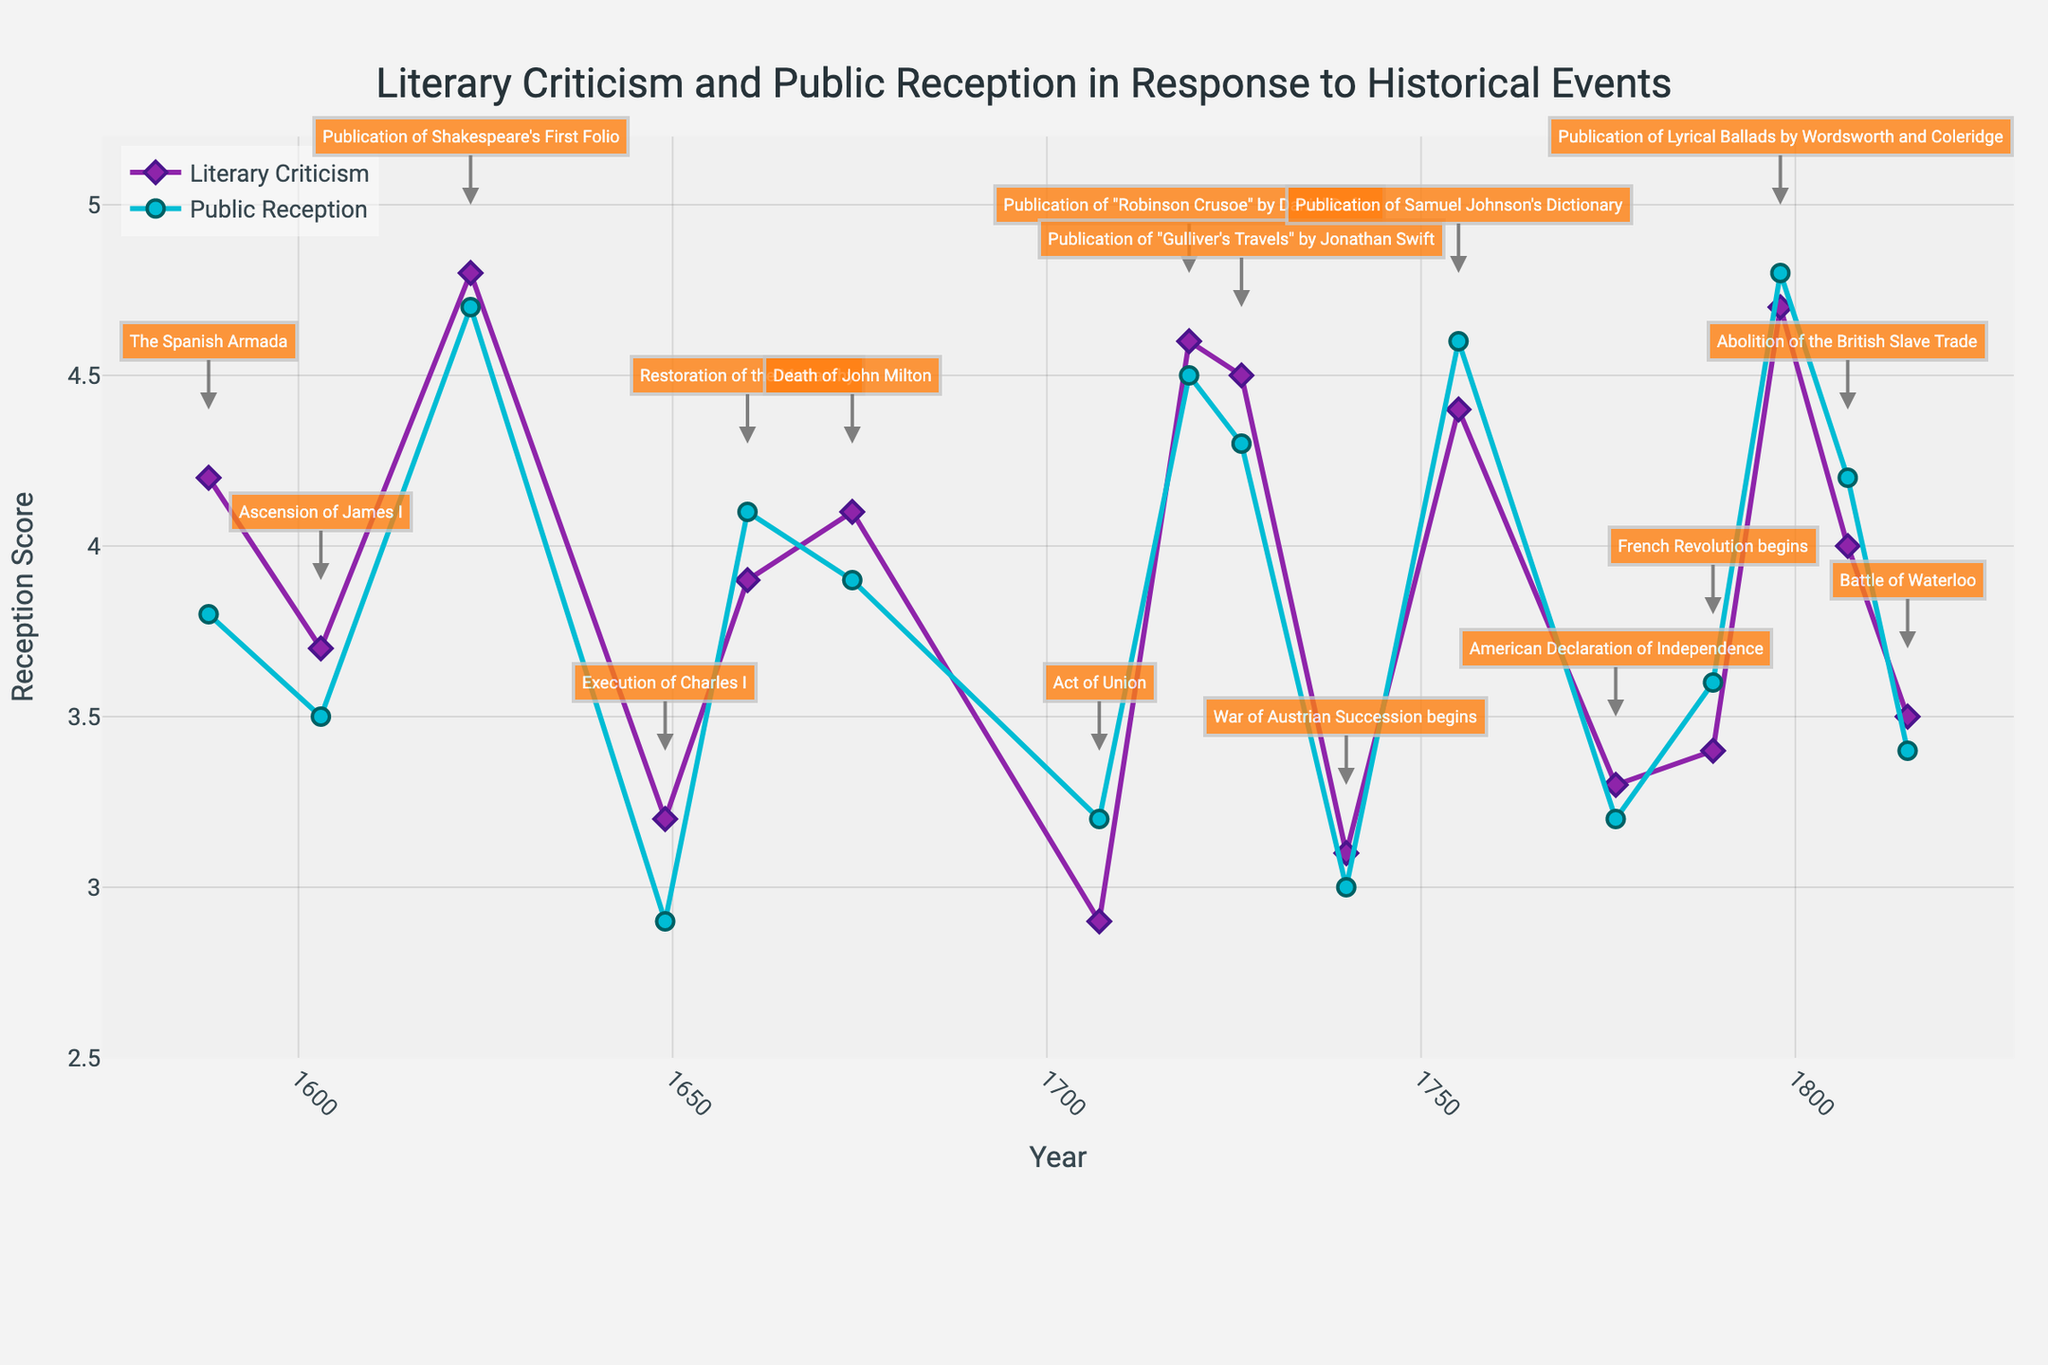what is the title of the chart? The title of the chart is displayed at the top and reads "Literary Criticism and Public Reception in Response to Historical Events".
Answer: Literary Criticism and Public Reception in Response to Historical Events Which years have the highest public reception scores? First, identify the public reception scores from the graph and cross-reference them with their respective years. The highest public reception scores are around 4.8 and 4.7, which correspond to the years 1798 and 1623 respectively.
Answer: 1798 and 1623 How many historical events are annotated in the plot? Count the number of annotations visible on the plot. Each annotation indicates a historical event. Based on the data provided, there are annotations for every year-event pair.
Answer: 15 What is the average literary criticism score for the events in the 18th century (1701-1800)? Identify the literary criticism scores between 1701 and 1800 from the dataset: 2.9 (1707), 4.6 (1719), 4.5 (1726), 3.1 (1740), 4.4 (1755), 3.3 (1776), 3.4 (1789). Sum these values and divide by the number of data points (7): (2.9 + 4.6 + 4.5 + 3.1 + 4.4 + 3.3 + 3.4) / 7 ≈ 3.74.
Answer: 3.74 Which historical event corresponds to the lowest literary criticism score, and what is the score? Look for the lowest point on the Literary Criticism trace and check the annotation. The lowest score is 2.9, corresponding to the Act of Union in 1707.
Answer: Act of Union 1707, 2.9 Compare the public reception scores of "Publication of Shakespeare's First Folio" and "Publication of Lyrical Ballads by Wordsworth and Coleridge". Which one is higher and by how much? Find the public reception scores for these events: 4.7 (1623) and 4.8 (1798). Calculate the difference: 4.8 - 4.7 = 0.1. The "Publication of Lyrical Ballads by Wordsworth and Coleridge" has a higher public reception score by 0.1.
Answer: Publication of Lyrical Ballads by Wordsworth and Coleridge, by 0.1 During which period do the Literary Criticism scores not show a significant decrease (less than 0.5 points)? By examining the plot, identify periods where Literary Criticism scores remain stable or do not drop significantly. From 1719 to 1736, and from 1649 to 1660, scores either increased or remained relatively stable within 0.5 points.
Answer: 1719 to 1726 and 1649 to 1660 Which event shows the largest discrepancy between literary criticism and public reception scores, and what is the difference? Calculate the difference between Literary Criticism and Public Reception scores for each event. The largest discrepancy is during Act of Union in 1707: Public Reception (3.2) - Literary Criticism (2.9) = 0.3.
Answer: Act of Union, 0.3 